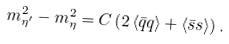Convert formula to latex. <formula><loc_0><loc_0><loc_500><loc_500>m _ { \eta ^ { \prime } } ^ { 2 } - m _ { \eta } ^ { 2 } = C \left ( 2 \left < \bar { q } q \right > + \left < \bar { s } s \right > \right ) .</formula> 